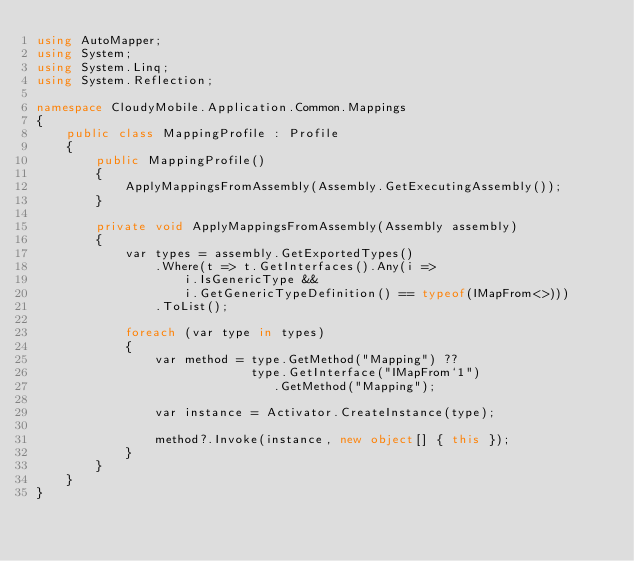<code> <loc_0><loc_0><loc_500><loc_500><_C#_>using AutoMapper;
using System;
using System.Linq;
using System.Reflection;

namespace CloudyMobile.Application.Common.Mappings
{
    public class MappingProfile : Profile
    {
        public MappingProfile()
        {
            ApplyMappingsFromAssembly(Assembly.GetExecutingAssembly());
        }

        private void ApplyMappingsFromAssembly(Assembly assembly)
        {
            var types = assembly.GetExportedTypes()
                .Where(t => t.GetInterfaces().Any(i =>
                    i.IsGenericType && 
                    i.GetGenericTypeDefinition() == typeof(IMapFrom<>)))
                .ToList();

            foreach (var type in types)
            {
                var method = type.GetMethod("Mapping") ??
                             type.GetInterface("IMapFrom`1")
                                .GetMethod("Mapping");

                var instance = Activator.CreateInstance(type);

                method?.Invoke(instance, new object[] { this });
            }
        }
    }
}</code> 